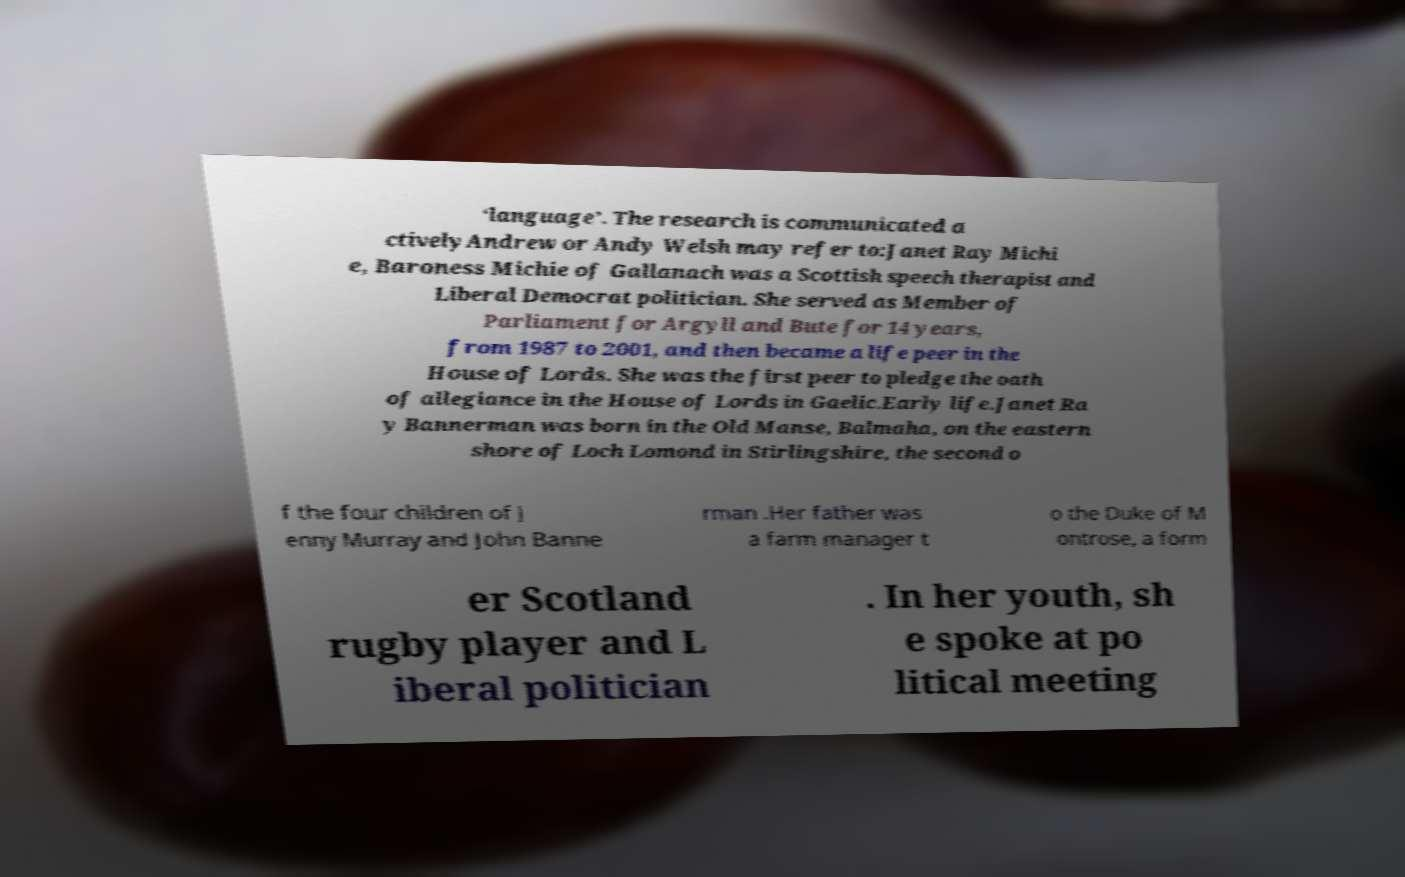Please read and relay the text visible in this image. What does it say? ‘language’. The research is communicated a ctivelyAndrew or Andy Welsh may refer to:Janet Ray Michi e, Baroness Michie of Gallanach was a Scottish speech therapist and Liberal Democrat politician. She served as Member of Parliament for Argyll and Bute for 14 years, from 1987 to 2001, and then became a life peer in the House of Lords. She was the first peer to pledge the oath of allegiance in the House of Lords in Gaelic.Early life.Janet Ra y Bannerman was born in the Old Manse, Balmaha, on the eastern shore of Loch Lomond in Stirlingshire, the second o f the four children of J enny Murray and John Banne rman .Her father was a farm manager t o the Duke of M ontrose, a form er Scotland rugby player and L iberal politician . In her youth, sh e spoke at po litical meeting 